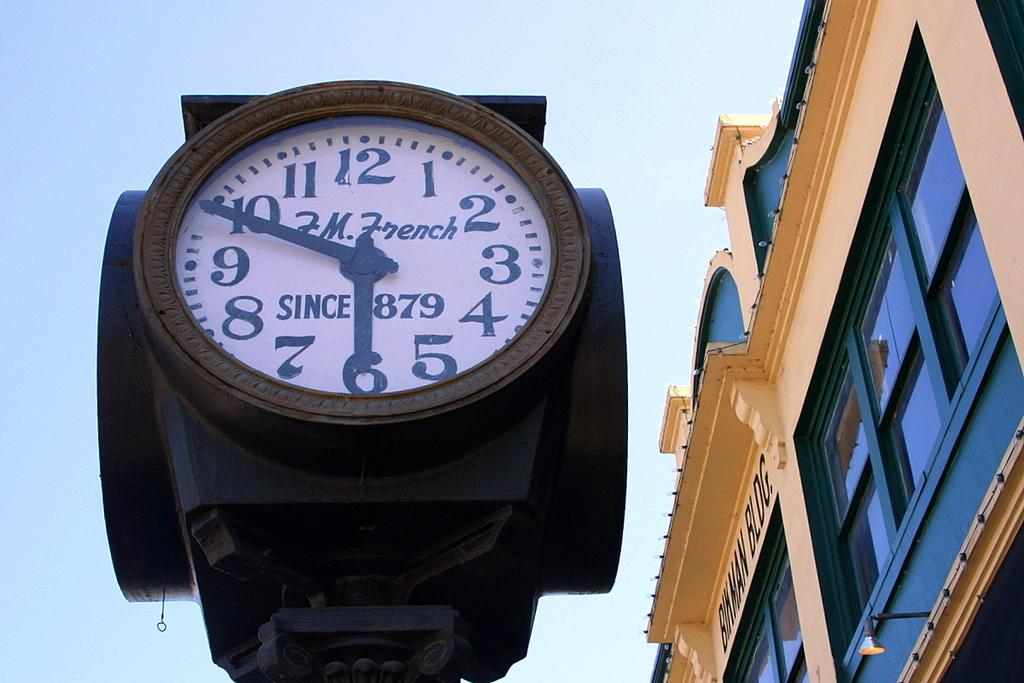<image>
Write a terse but informative summary of the picture. A clock bearing the name F.M. French shows the time of 5:49. 